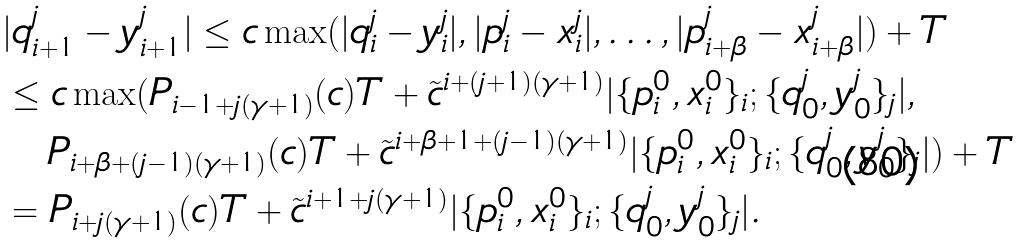Convert formula to latex. <formula><loc_0><loc_0><loc_500><loc_500>& | q _ { i + 1 } ^ { j } - y _ { i + 1 } ^ { j } | \leq c \max ( | q _ { i } ^ { j } - y _ { i } ^ { j } | , | p _ { i } ^ { j } - x _ { i } ^ { j } | , \dots , | p _ { i + \beta } ^ { j } - x _ { i + \beta } ^ { j } | ) + T \\ & \leq c \max ( P _ { i - 1 + j ( \gamma + 1 ) } ( c ) T + \tilde { c } ^ { i + ( j + 1 ) ( \gamma + 1 ) } | \{ p _ { i } ^ { 0 } , x _ { i } ^ { 0 } \} _ { i } ; \{ q ^ { j } _ { 0 } , y ^ { j } _ { 0 } \} _ { j } | , \\ & \quad P _ { i + \beta + ( j - 1 ) ( \gamma + 1 ) } ( c ) T + \tilde { c } ^ { i + \beta + 1 + ( j - 1 ) ( \gamma + 1 ) } | \{ p _ { i } ^ { 0 } , x _ { i } ^ { 0 } \} _ { i } ; \{ q ^ { j } _ { 0 } , y ^ { j } _ { 0 } \} _ { j } | ) + T \\ & = P _ { i + j ( \gamma + 1 ) } ( c ) T + \tilde { c } ^ { i + 1 + j ( \gamma + 1 ) } | \{ p _ { i } ^ { 0 } , x _ { i } ^ { 0 } \} _ { i } ; \{ q ^ { j } _ { 0 } , y ^ { j } _ { 0 } \} _ { j } | .</formula> 